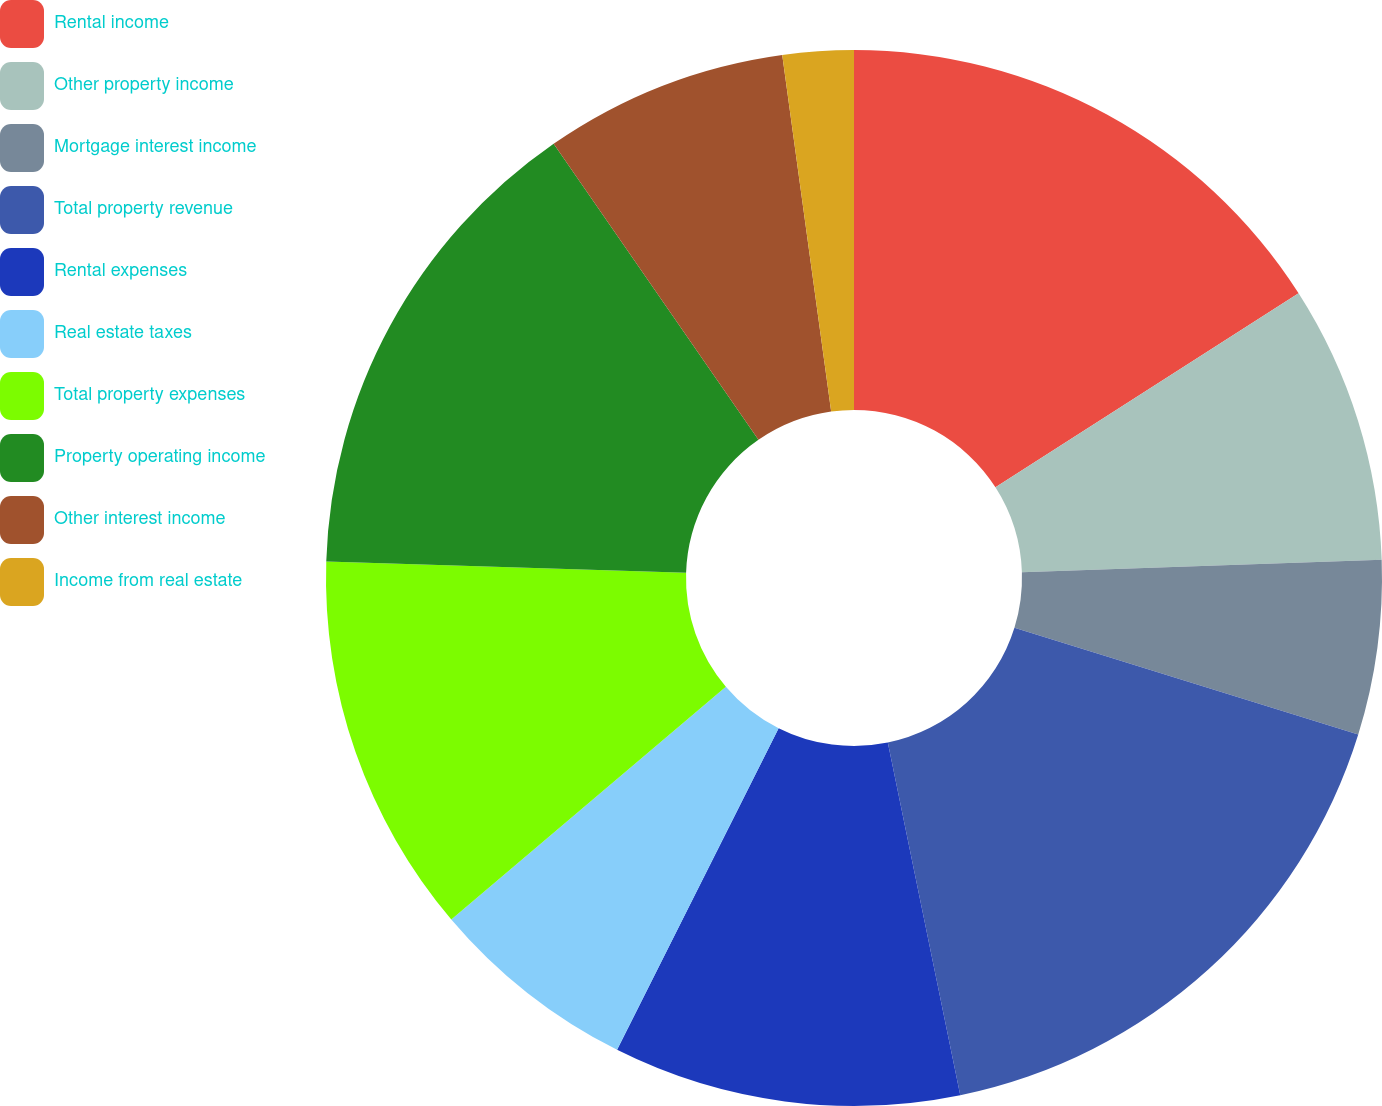<chart> <loc_0><loc_0><loc_500><loc_500><pie_chart><fcel>Rental income<fcel>Other property income<fcel>Mortgage interest income<fcel>Total property revenue<fcel>Rental expenses<fcel>Real estate taxes<fcel>Total property expenses<fcel>Property operating income<fcel>Other interest income<fcel>Income from real estate<nl><fcel>15.93%<fcel>8.52%<fcel>5.34%<fcel>16.98%<fcel>10.63%<fcel>6.4%<fcel>11.69%<fcel>14.87%<fcel>7.46%<fcel>2.17%<nl></chart> 